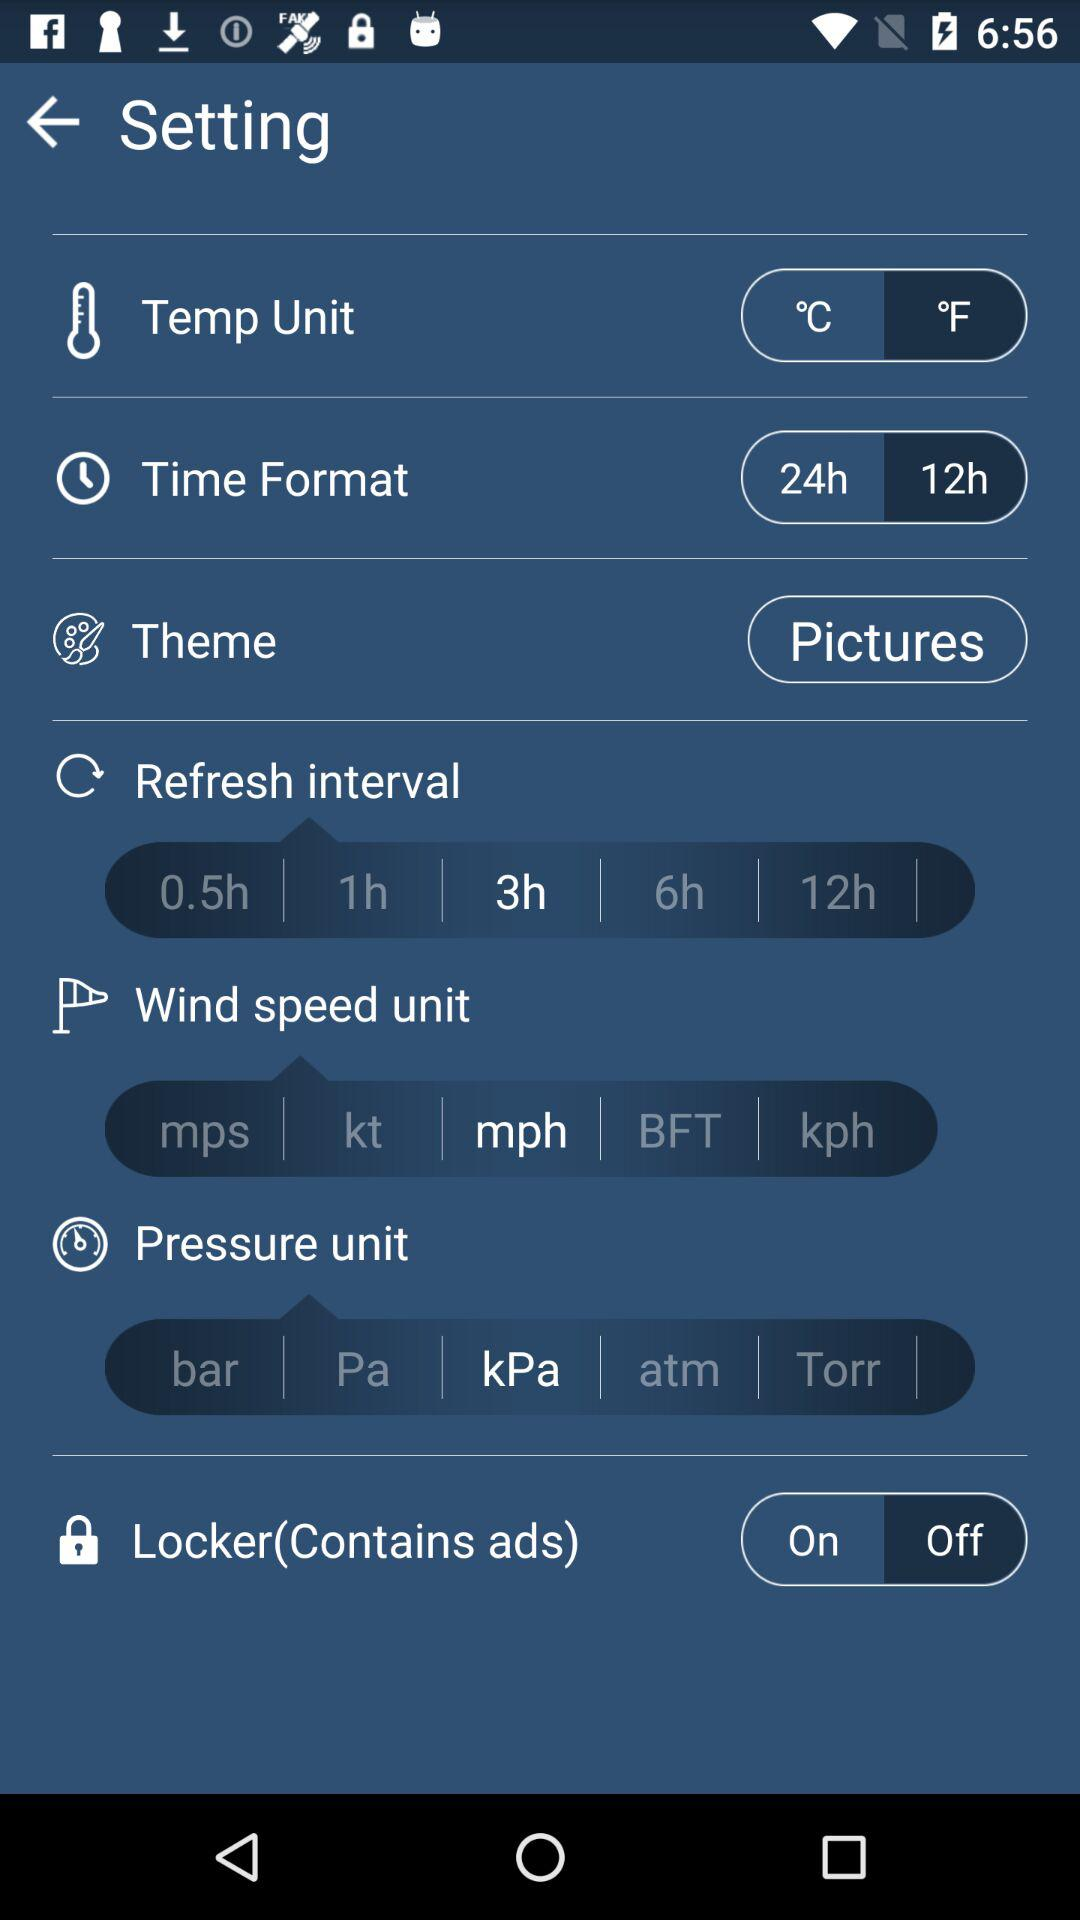What is the status of "Locker(Contains ads)"? The status is "on". 